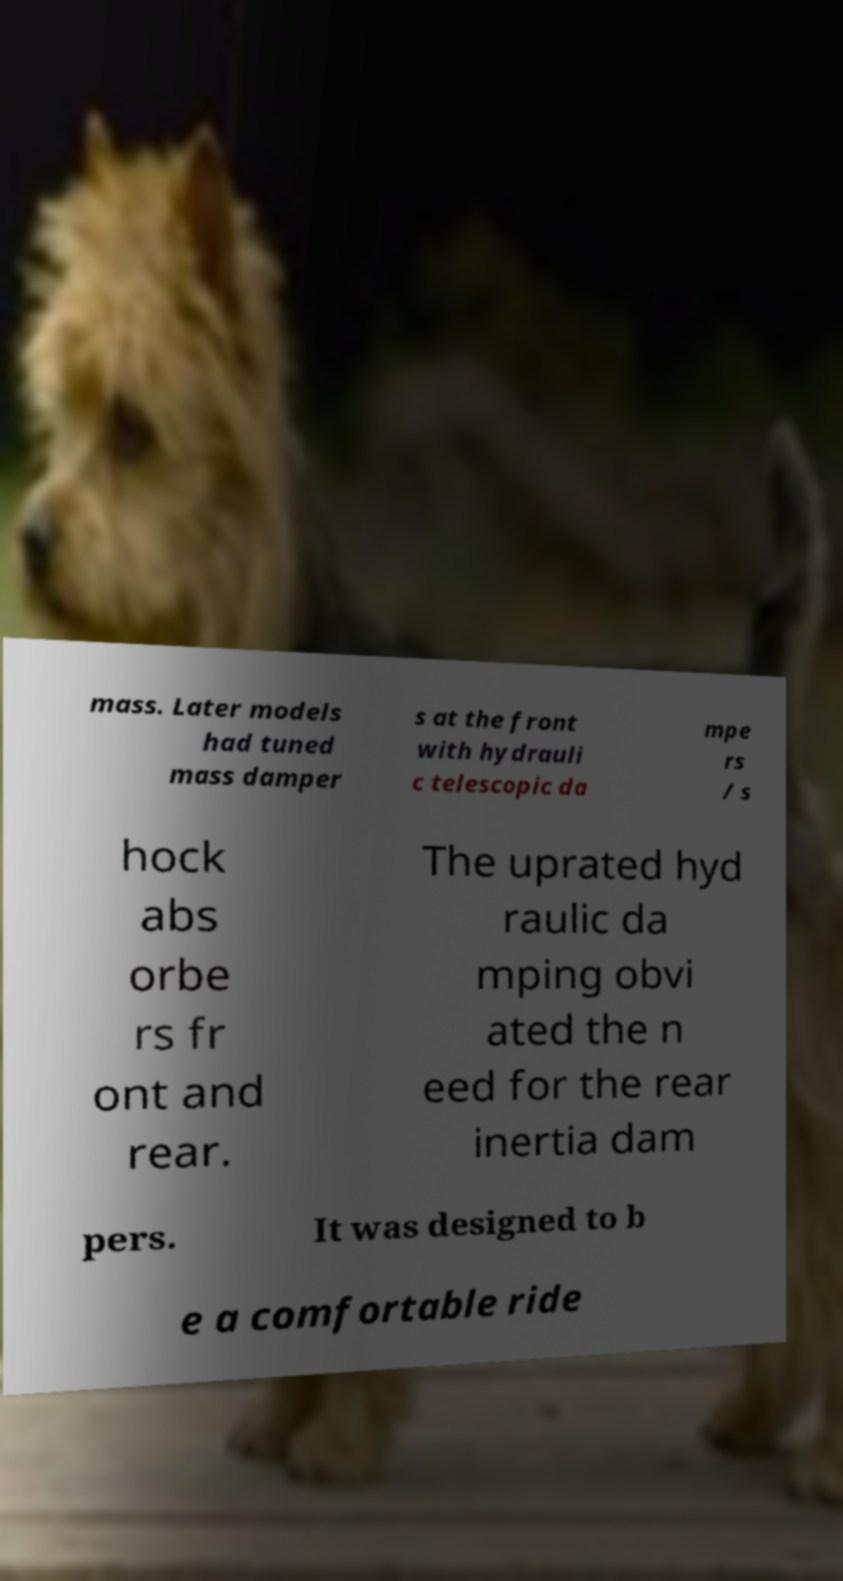Can you accurately transcribe the text from the provided image for me? mass. Later models had tuned mass damper s at the front with hydrauli c telescopic da mpe rs / s hock abs orbe rs fr ont and rear. The uprated hyd raulic da mping obvi ated the n eed for the rear inertia dam pers. It was designed to b e a comfortable ride 